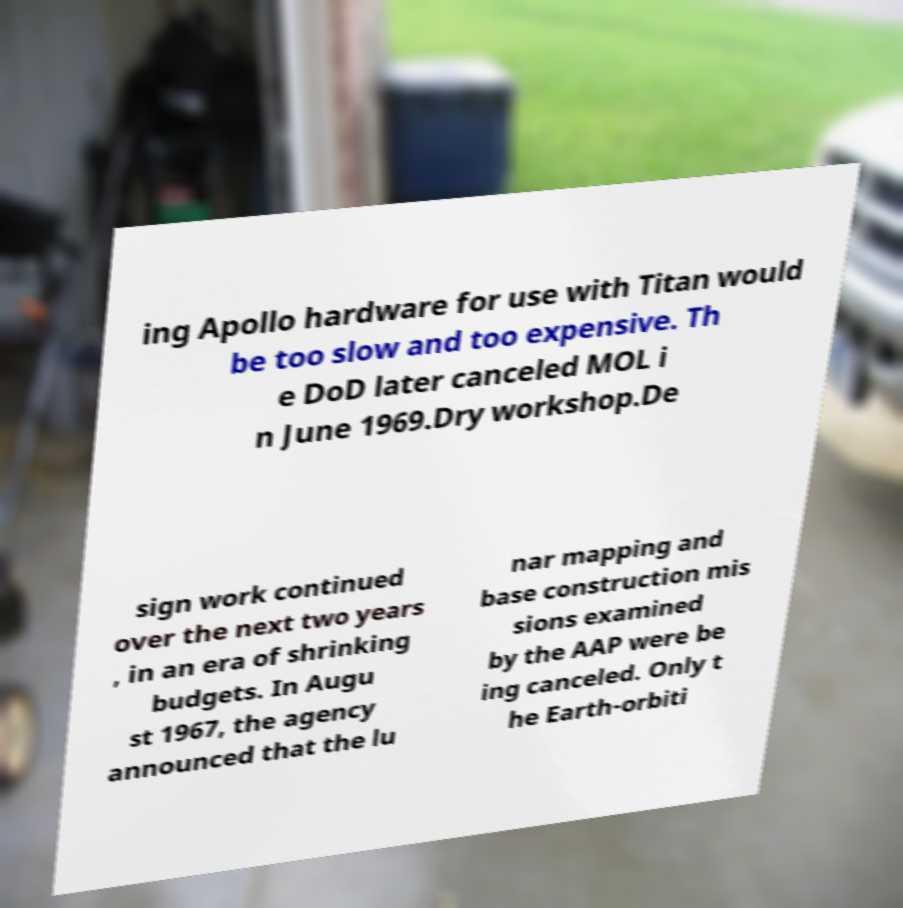For documentation purposes, I need the text within this image transcribed. Could you provide that? ing Apollo hardware for use with Titan would be too slow and too expensive. Th e DoD later canceled MOL i n June 1969.Dry workshop.De sign work continued over the next two years , in an era of shrinking budgets. In Augu st 1967, the agency announced that the lu nar mapping and base construction mis sions examined by the AAP were be ing canceled. Only t he Earth-orbiti 